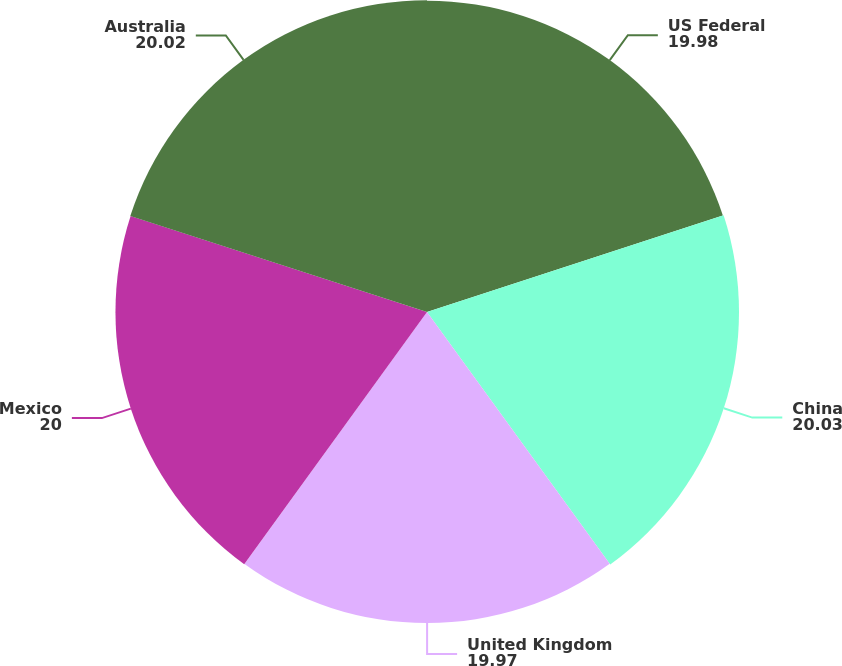Convert chart. <chart><loc_0><loc_0><loc_500><loc_500><pie_chart><fcel>US Federal<fcel>China<fcel>United Kingdom<fcel>Mexico<fcel>Australia<nl><fcel>19.98%<fcel>20.03%<fcel>19.97%<fcel>20.0%<fcel>20.02%<nl></chart> 